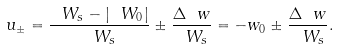Convert formula to latex. <formula><loc_0><loc_0><loc_500><loc_500>u _ { \pm } = \frac { \ W _ { s } - | \ W _ { 0 } | } { \ W _ { s } } \pm \frac { \Delta \ w } { \ W _ { s } } = - w _ { 0 } \pm \frac { \Delta \ w } { \ W _ { s } } .</formula> 